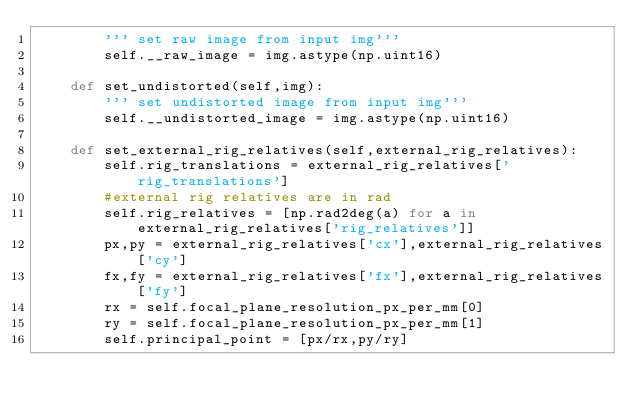<code> <loc_0><loc_0><loc_500><loc_500><_Python_>        ''' set raw image from input img'''
        self.__raw_image = img.astype(np.uint16)
        
    def set_undistorted(self,img):
        ''' set undistorted image from input img'''
        self.__undistorted_image = img.astype(np.uint16)
        
    def set_external_rig_relatives(self,external_rig_relatives):
        self.rig_translations = external_rig_relatives['rig_translations']
        #external rig relatives are in rad
        self.rig_relatives = [np.rad2deg(a) for a in external_rig_relatives['rig_relatives']]
        px,py = external_rig_relatives['cx'],external_rig_relatives['cy']
        fx,fy = external_rig_relatives['fx'],external_rig_relatives['fy']
        rx = self.focal_plane_resolution_px_per_mm[0]
        ry = self.focal_plane_resolution_px_per_mm[1]
        self.principal_point = [px/rx,py/ry]</code> 